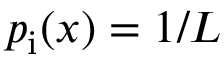Convert formula to latex. <formula><loc_0><loc_0><loc_500><loc_500>p _ { i } ( x ) = 1 / L</formula> 